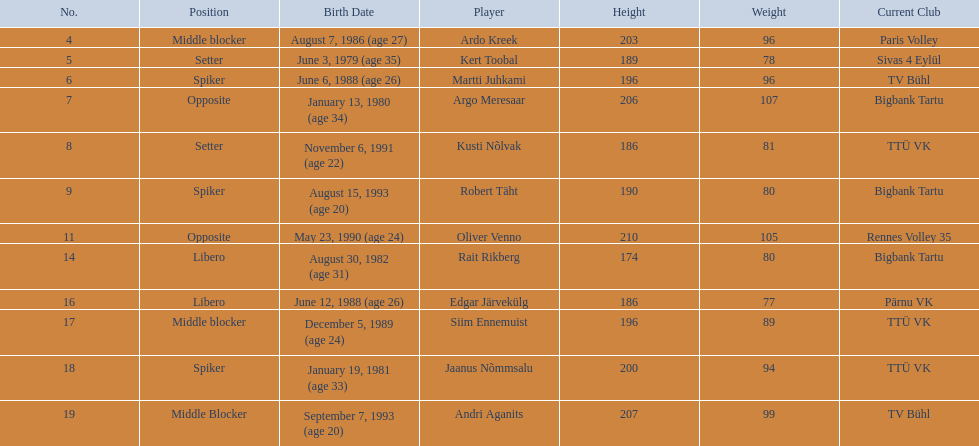What are the total number of players from france? 2. 